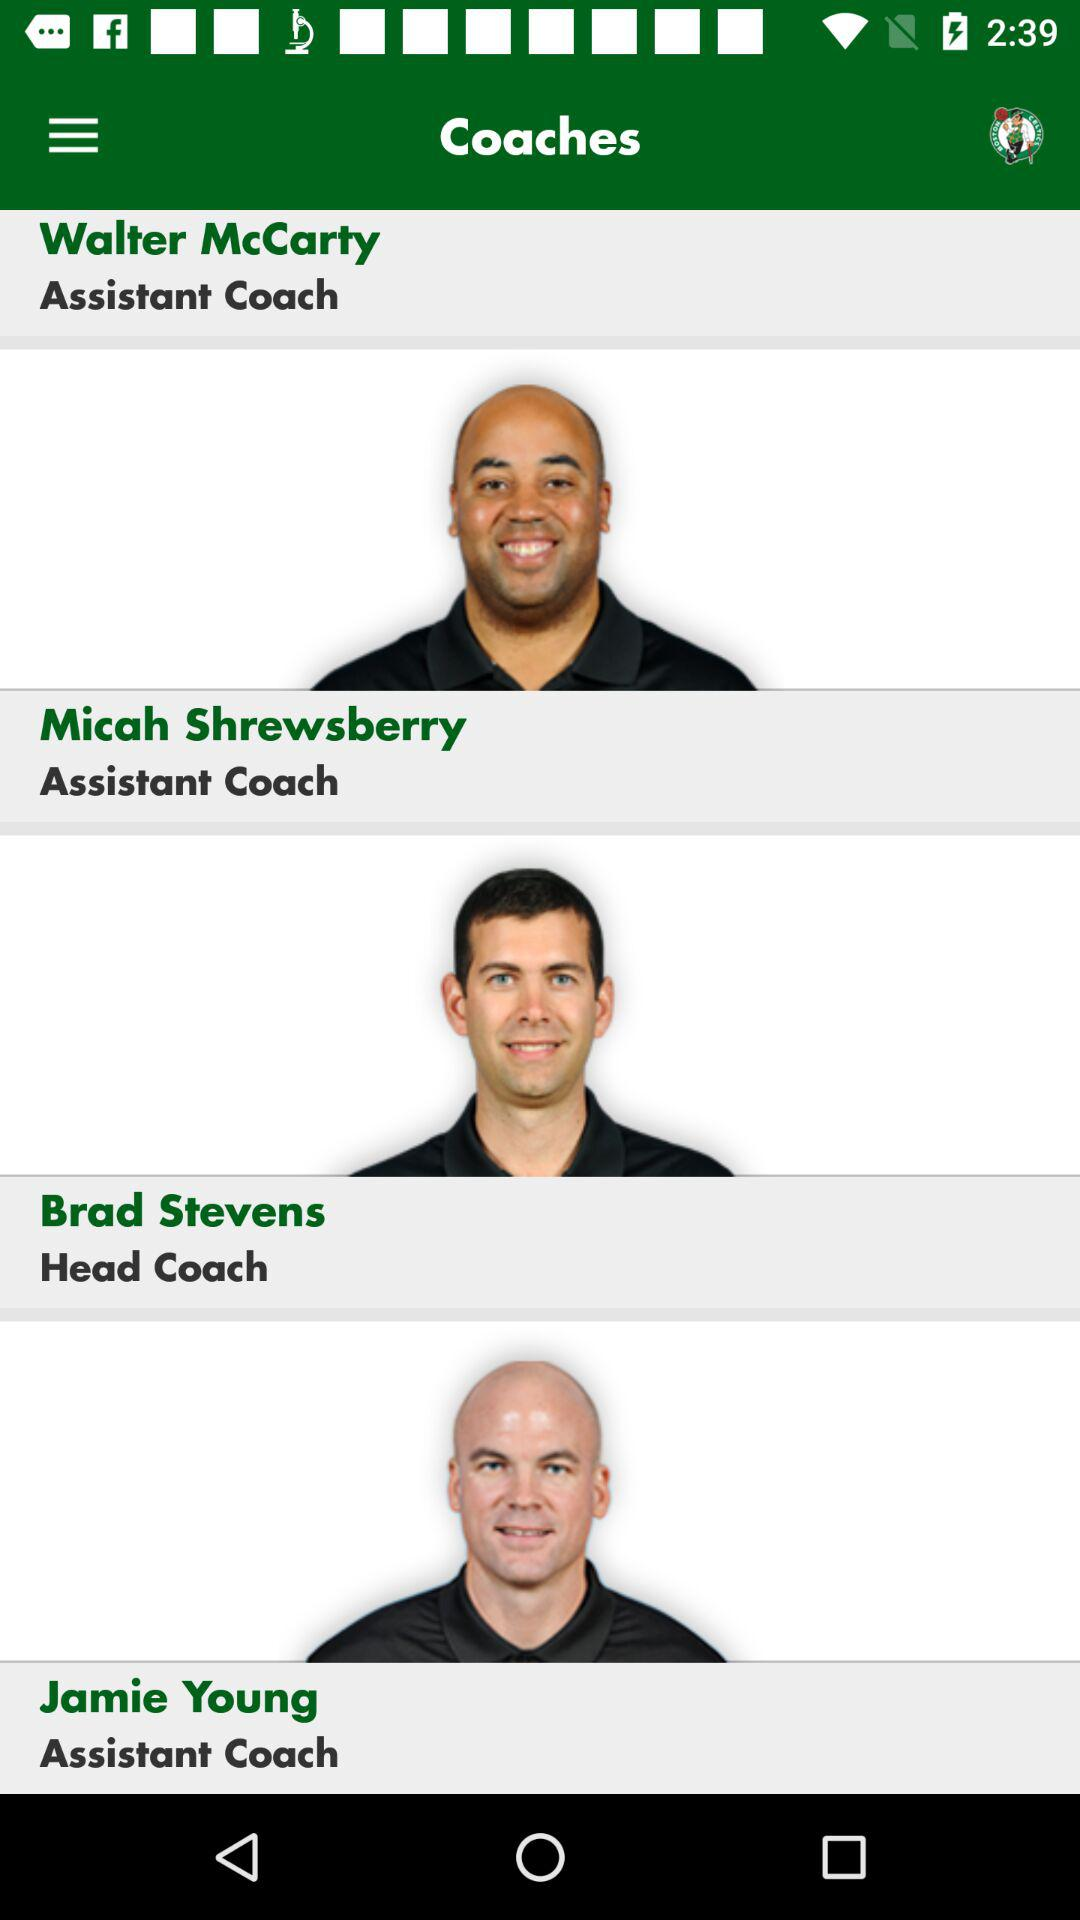How many coaches are there on the team?
Answer the question using a single word or phrase. 4 